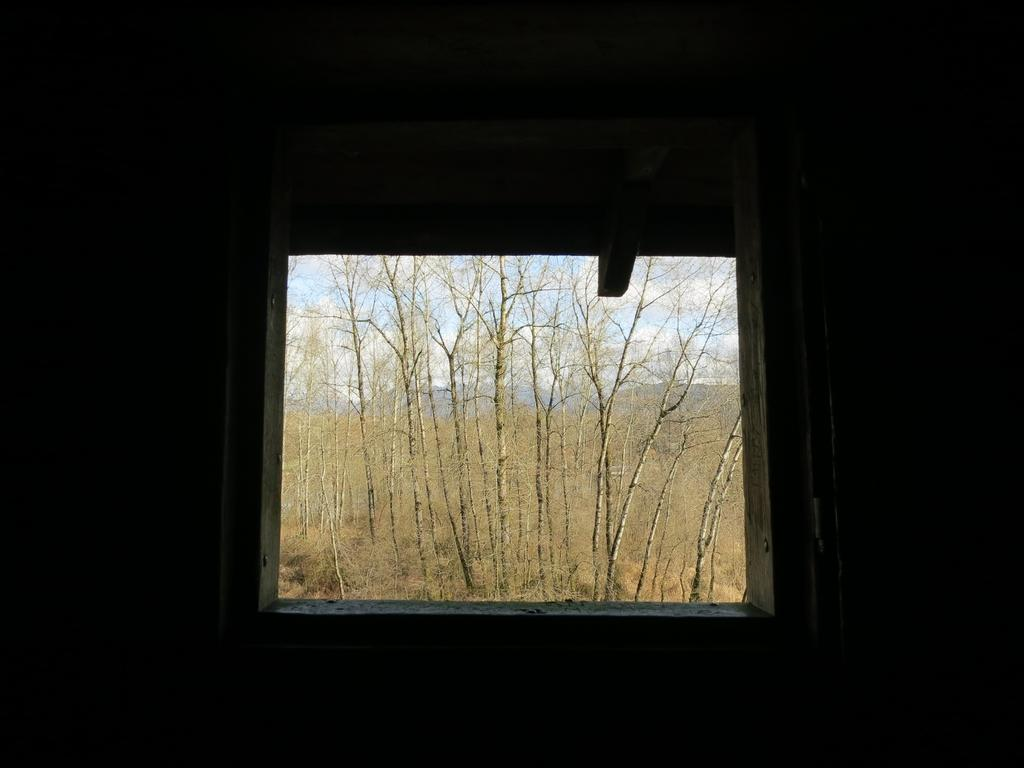What can be seen in the image that provides a view of the outdoors? There is a window in the image that provides a view of the outdoors. What type of vegetation is visible in the image? There are dried trees in the image. What is visible in the background of the image? There is a sky visible in the background of the image. What is the rate of the alarm in the image? There is no rate or alarm present in the image. 